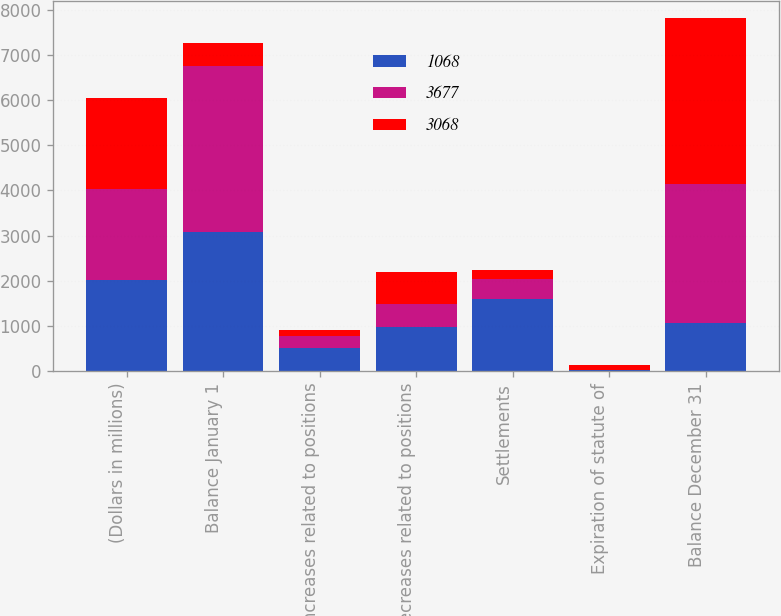Convert chart to OTSL. <chart><loc_0><loc_0><loc_500><loc_500><stacked_bar_chart><ecel><fcel>(Dollars in millions)<fcel>Balance January 1<fcel>Increases related to positions<fcel>Decreases related to positions<fcel>Settlements<fcel>Expiration of statute of<fcel>Balance December 31<nl><fcel>1068<fcel>2014<fcel>3068<fcel>519<fcel>973<fcel>1594<fcel>27<fcel>1068<nl><fcel>3677<fcel>2013<fcel>3677<fcel>254<fcel>508<fcel>448<fcel>5<fcel>3068<nl><fcel>3068<fcel>2012<fcel>519<fcel>142<fcel>711<fcel>205<fcel>104<fcel>3677<nl></chart> 